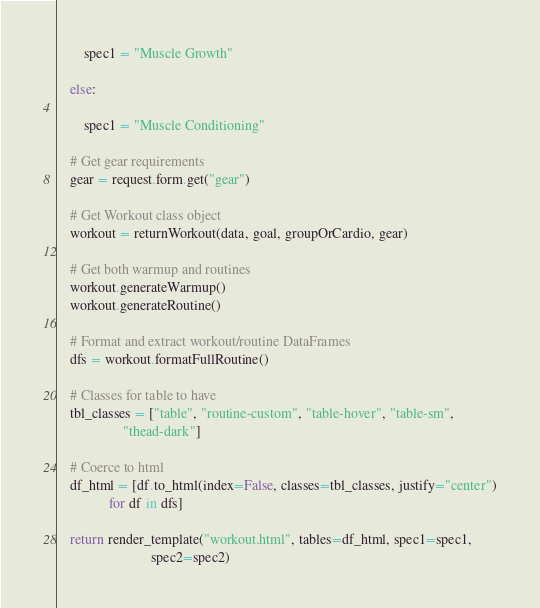<code> <loc_0><loc_0><loc_500><loc_500><_Python_>
        spec1 = "Muscle Growth"

    else:

        spec1 = "Muscle Conditioning"

    # Get gear requirements
    gear = request.form.get("gear")

    # Get Workout class object
    workout = returnWorkout(data, goal, groupOrCardio, gear)

    # Get both warmup and routines
    workout.generateWarmup()
    workout.generateRoutine()

    # Format and extract workout/routine DataFrames
    dfs = workout.formatFullRoutine()

    # Classes for table to have
    tbl_classes = ["table", "routine-custom", "table-hover", "table-sm",
                   "thead-dark"]

    # Coerce to html
    df_html = [df.to_html(index=False, classes=tbl_classes, justify="center")
               for df in dfs]

    return render_template("workout.html", tables=df_html, spec1=spec1,
                           spec2=spec2)

</code> 